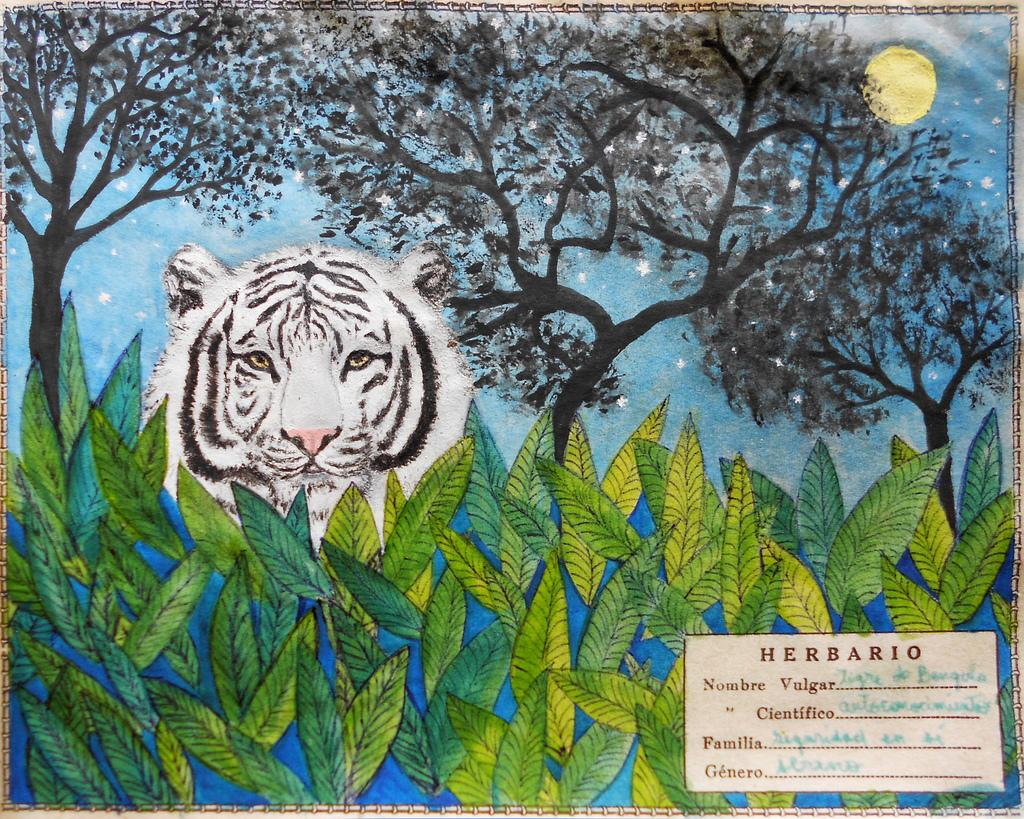What is depicted on the poster in the image? There is a poster with a painting in the image. Can you describe the animal in the image? There is an animal in the image, but without more specific information, we cannot provide further details. What type of vegetation is present in the image? There are plants and trees in the image. What can be seen in the sky in the image? The sky is visible in the image, and the sun and stars are also visible. What is written on the poster? There is text written on the poster. How many bananas are being carried by the minister in the image? There is no minister or bananas present in the image. What type of lumber is being used to construct the animal in the image? There is no lumber or construction process depicted in the image; it features a poster with a painting, an animal, plants, trees, and text. 